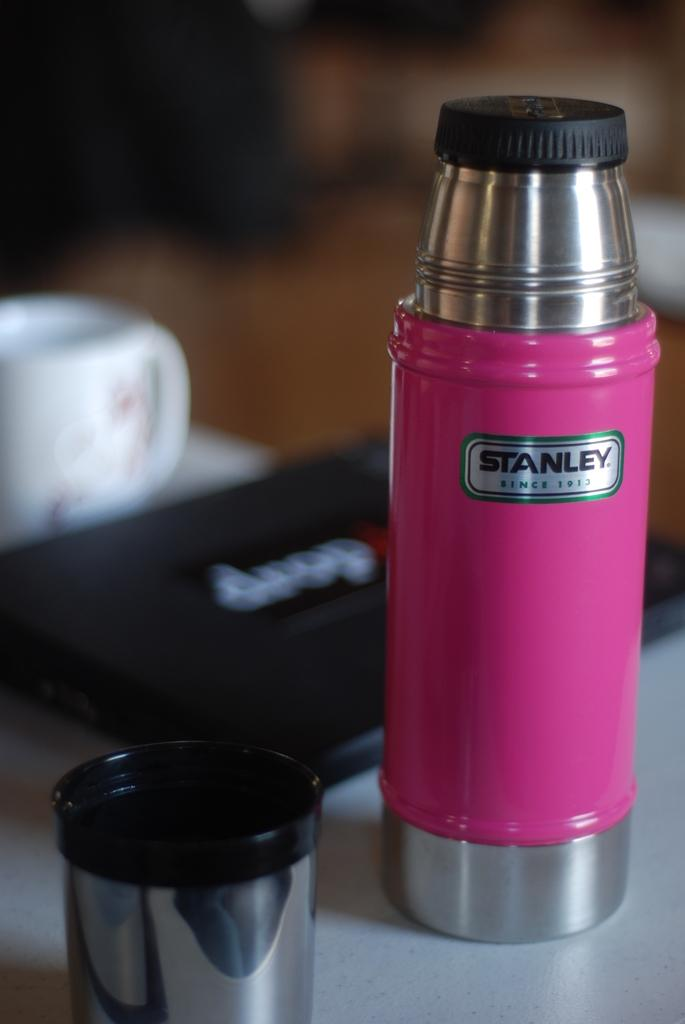What is the main object in the center of the image? There is a table in the center of the image. What items can be seen on the table? There is a cup, a glass, a bottle, and a black color object on the table. Can you describe the background of the image? The background of the image is blurry. What type of shoes is the governor wearing in the image? There is no governor or shoes present in the image. How is the grandfather interacting with the black color object in the image? There is no grandfather present in the image, and the black color object is not interacting with any person. 